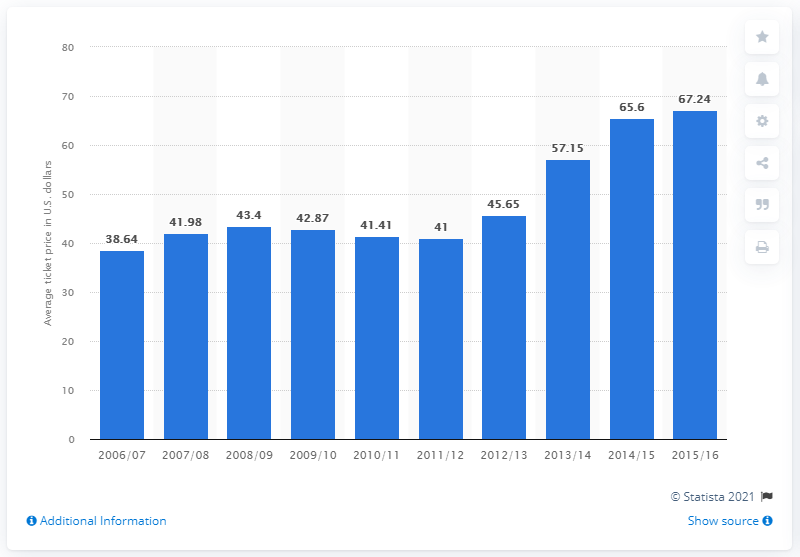Highlight a few significant elements in this photo. In the 2006/2007 season, the average ticket price for Houston Rockets games was $38.64. 